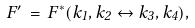Convert formula to latex. <formula><loc_0><loc_0><loc_500><loc_500>F ^ { \prime } \, = \, F ^ { * } ( k _ { 1 } , k _ { 2 } \leftrightarrow k _ { 3 } , k _ { 4 } ) ,</formula> 